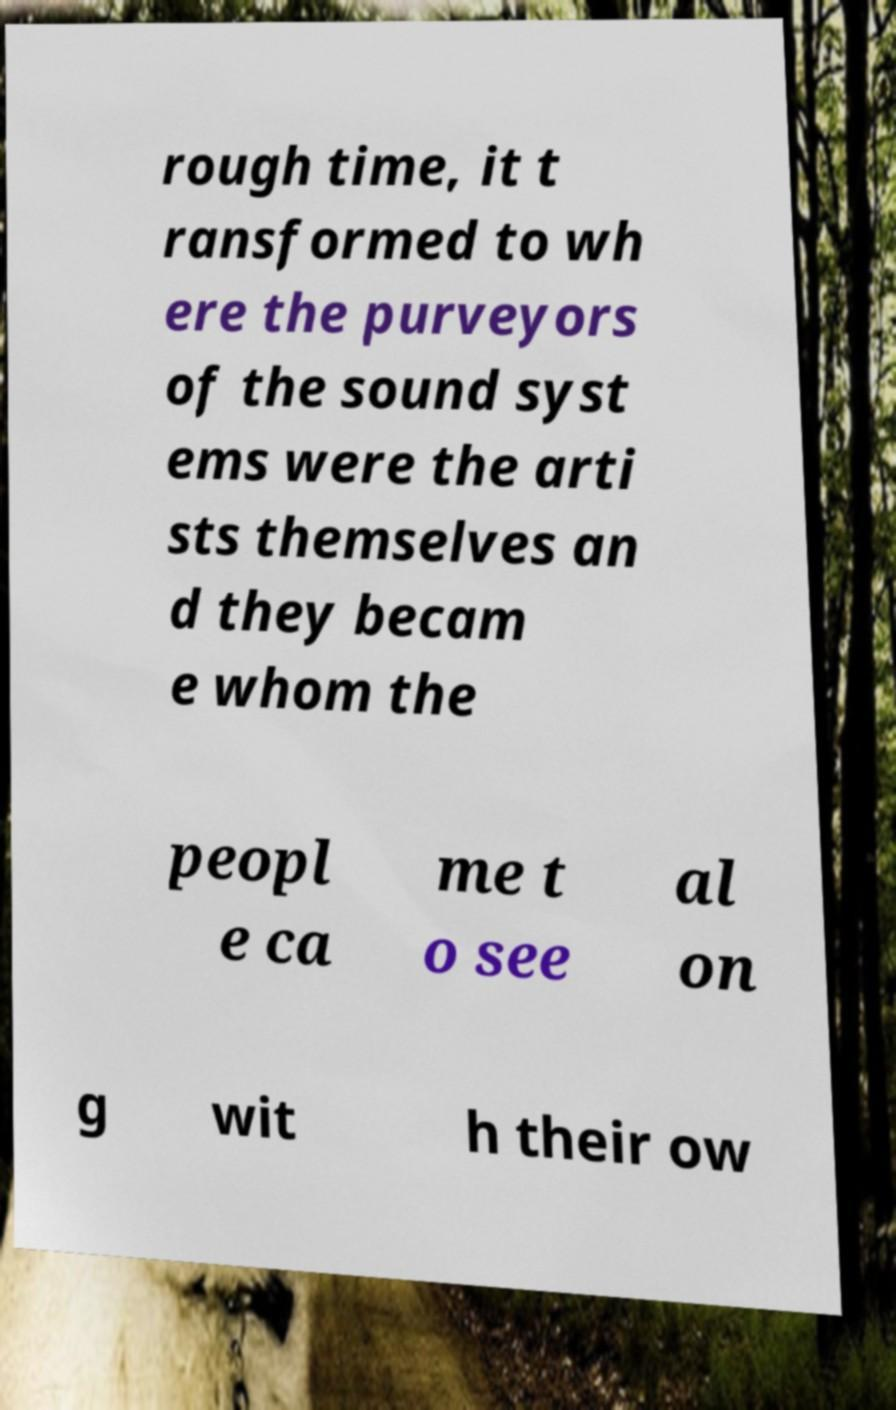There's text embedded in this image that I need extracted. Can you transcribe it verbatim? rough time, it t ransformed to wh ere the purveyors of the sound syst ems were the arti sts themselves an d they becam e whom the peopl e ca me t o see al on g wit h their ow 